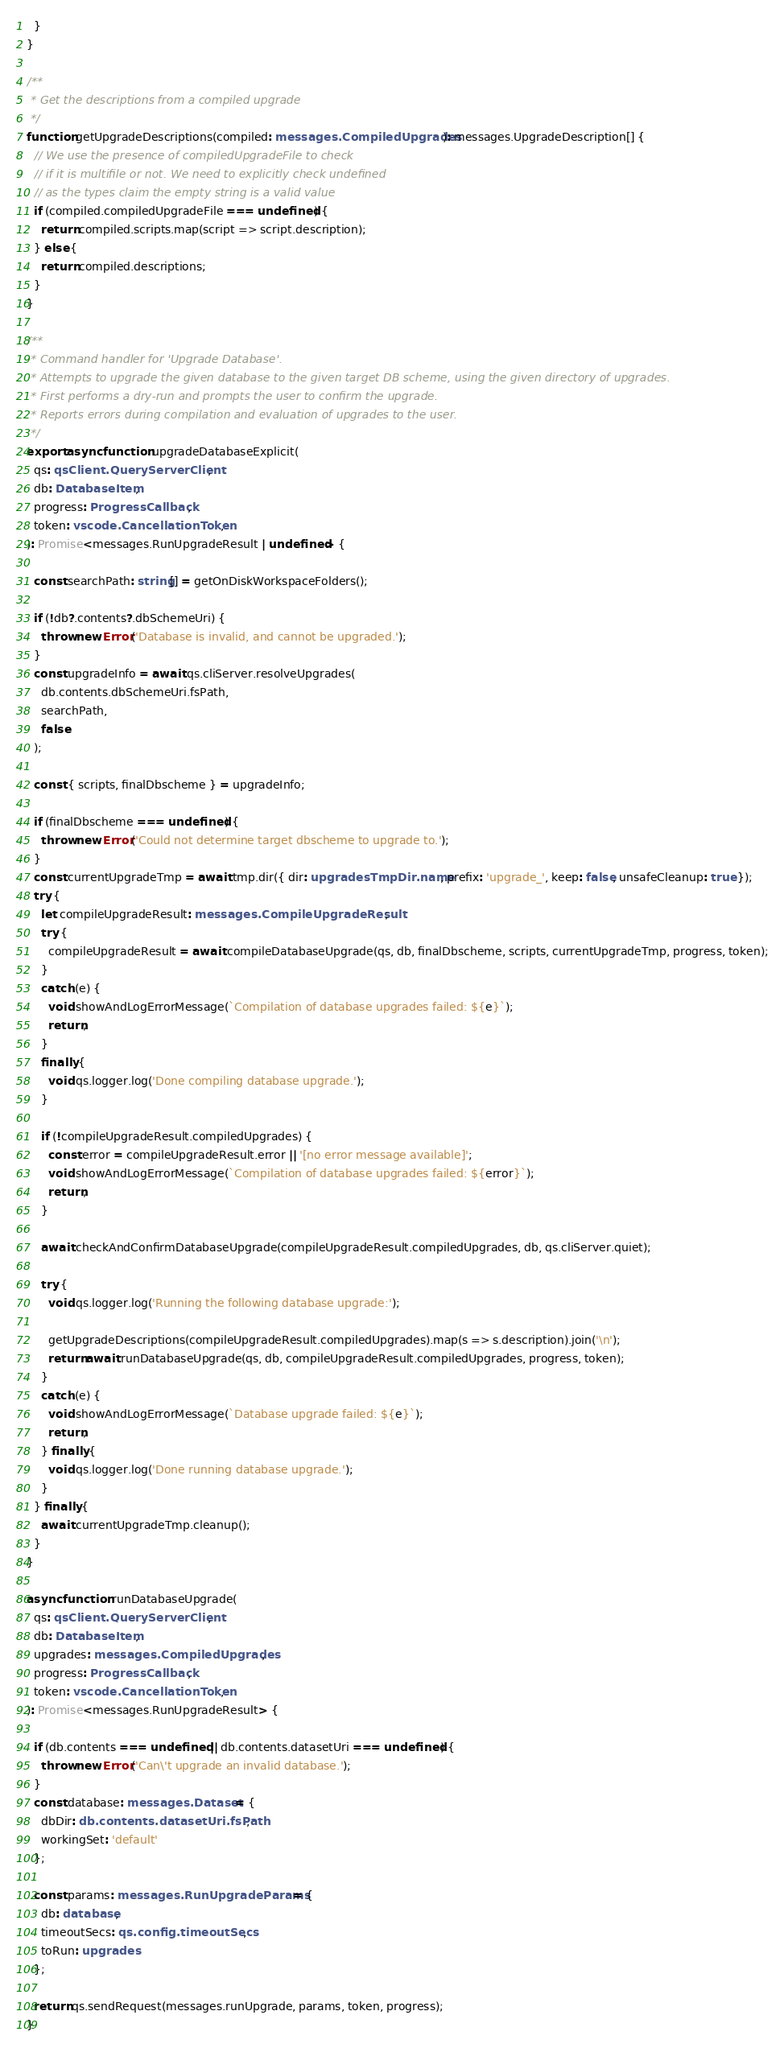<code> <loc_0><loc_0><loc_500><loc_500><_TypeScript_>  }
}

/**
 * Get the descriptions from a compiled upgrade
 */
function getUpgradeDescriptions(compiled: messages.CompiledUpgrades): messages.UpgradeDescription[] {
  // We use the presence of compiledUpgradeFile to check
  // if it is multifile or not. We need to explicitly check undefined
  // as the types claim the empty string is a valid value
  if (compiled.compiledUpgradeFile === undefined) {
    return compiled.scripts.map(script => script.description);
  } else {
    return compiled.descriptions;
  }
}

/**
 * Command handler for 'Upgrade Database'.
 * Attempts to upgrade the given database to the given target DB scheme, using the given directory of upgrades.
 * First performs a dry-run and prompts the user to confirm the upgrade.
 * Reports errors during compilation and evaluation of upgrades to the user.
 */
export async function upgradeDatabaseExplicit(
  qs: qsClient.QueryServerClient,
  db: DatabaseItem,
  progress: ProgressCallback,
  token: vscode.CancellationToken,
): Promise<messages.RunUpgradeResult | undefined> {

  const searchPath: string[] = getOnDiskWorkspaceFolders();

  if (!db?.contents?.dbSchemeUri) {
    throw new Error('Database is invalid, and cannot be upgraded.');
  }
  const upgradeInfo = await qs.cliServer.resolveUpgrades(
    db.contents.dbSchemeUri.fsPath,
    searchPath,
    false
  );

  const { scripts, finalDbscheme } = upgradeInfo;

  if (finalDbscheme === undefined) {
    throw new Error('Could not determine target dbscheme to upgrade to.');
  }
  const currentUpgradeTmp = await tmp.dir({ dir: upgradesTmpDir.name, prefix: 'upgrade_', keep: false, unsafeCleanup: true });
  try {
    let compileUpgradeResult: messages.CompileUpgradeResult;
    try {
      compileUpgradeResult = await compileDatabaseUpgrade(qs, db, finalDbscheme, scripts, currentUpgradeTmp, progress, token);
    }
    catch (e) {
      void showAndLogErrorMessage(`Compilation of database upgrades failed: ${e}`);
      return;
    }
    finally {
      void qs.logger.log('Done compiling database upgrade.');
    }

    if (!compileUpgradeResult.compiledUpgrades) {
      const error = compileUpgradeResult.error || '[no error message available]';
      void showAndLogErrorMessage(`Compilation of database upgrades failed: ${error}`);
      return;
    }

    await checkAndConfirmDatabaseUpgrade(compileUpgradeResult.compiledUpgrades, db, qs.cliServer.quiet);

    try {
      void qs.logger.log('Running the following database upgrade:');

      getUpgradeDescriptions(compileUpgradeResult.compiledUpgrades).map(s => s.description).join('\n');
      return await runDatabaseUpgrade(qs, db, compileUpgradeResult.compiledUpgrades, progress, token);
    }
    catch (e) {
      void showAndLogErrorMessage(`Database upgrade failed: ${e}`);
      return;
    } finally {
      void qs.logger.log('Done running database upgrade.');
    }
  } finally {
    await currentUpgradeTmp.cleanup();
  }
}

async function runDatabaseUpgrade(
  qs: qsClient.QueryServerClient,
  db: DatabaseItem,
  upgrades: messages.CompiledUpgrades,
  progress: ProgressCallback,
  token: vscode.CancellationToken,
): Promise<messages.RunUpgradeResult> {

  if (db.contents === undefined || db.contents.datasetUri === undefined) {
    throw new Error('Can\'t upgrade an invalid database.');
  }
  const database: messages.Dataset = {
    dbDir: db.contents.datasetUri.fsPath,
    workingSet: 'default'
  };

  const params: messages.RunUpgradeParams = {
    db: database,
    timeoutSecs: qs.config.timeoutSecs,
    toRun: upgrades
  };

  return qs.sendRequest(messages.runUpgrade, params, token, progress);
}
</code> 